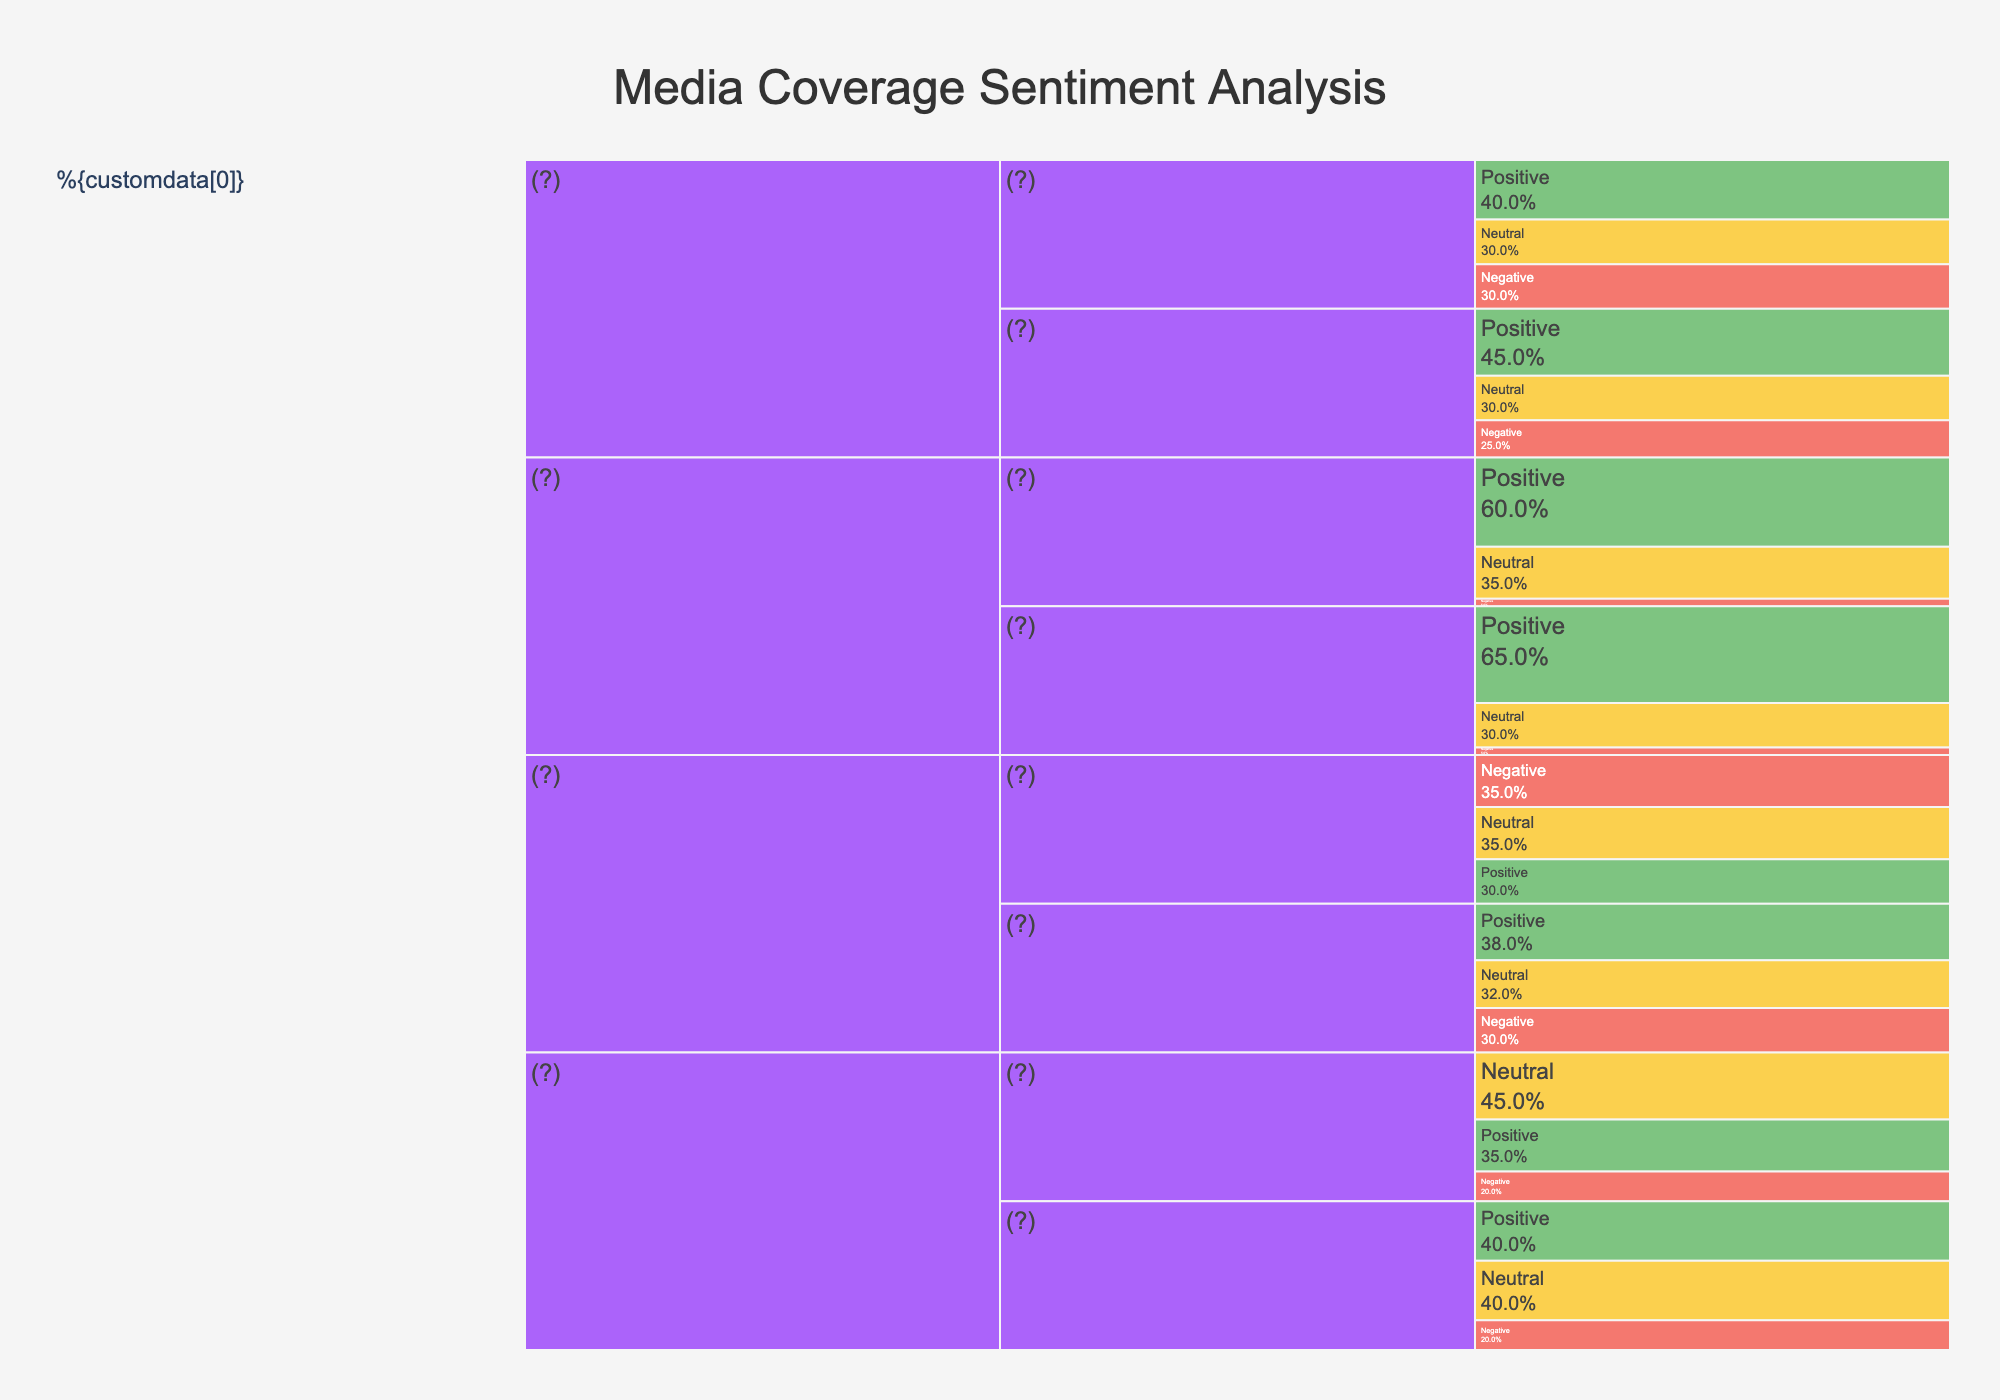What is the percentage of positive sentiment in Traditional Media during Q1 2023? To find the percentage of positive sentiment in Traditional Media during Q1 2023, look at the segment labeled 'Traditional Media > Q1 2023 > Positive' in the icicle chart. The percentage shown is 35%.
Answer: 35% What is the overall sentiment trend for Press Releases from Q1 to Q2 2023? Compare the sentiments (positive, neutral, negative) for Press Releases between Q1 and Q2 2023. Positive sentiment increased from 60% to 65%, neutral sentiment decreased from 35% to 30%, and negative sentiment remained constant at 5%. Thus, positive sentiment increased and neutral decreased while negative sentiment stayed the same.
Answer: Positive increased, neutral decreased, negative constant In which communication channel did the negative sentiment decrease the most from Q1 to Q2 2023? To determine where negative sentiment decreased the most, compare the negative sentiment percentages across all channels from Q1 to Q2. Social Media negative sentiment decreased from 35% to 30%, which is the largest decrease. Other channels showed no decrease or smaller changes.
Answer: Social Media How does the neutral sentiment in Traditional Media during Q1 2023 compare to that in Social Media during the same period? Examine both neutral sentiments for Traditional Media and Social Media in Q1 2023. Traditional Media has 45% neutral sentiment, whereas Social Media has 35%. Therefore, Traditional Media has a higher neutral sentiment.
Answer: Traditional Media has higher neutral sentiment What is the total percentage of positive sentiment across all communication channels in Q2 2023? Add the positive percentages for all channels in Q2 2023: Traditional Media (40%), Social Media (38%), Press Releases (65%), and Customer Reviews (45%). The total is 40% + 38% + 65% + 45% = 188%.
Answer: 188% Which channel had the highest percentage of negative sentiment in Q1 2023, and what was the percentage? Look for the highest negative sentiment percentage in Q1 2023 across all channels. Social Media has the highest negative sentiment at 35%.
Answer: Social Media, 35% Which communication channel showed the least change in negative sentiment from Q1 to Q2 2023? Investigate the change in negative sentiment across all channels from Q1 to Q2 2023. Both Press Releases and Traditional Media saw no change, with 5% and 20% respectively in both quarters. However, Social Media and Customer Reviews saw changes.
Answer: Press Releases and Traditional Media Is there any channel where the neutral sentiment remained the same from Q1 to Q2 2023? Compare the neutral sentiment percentages from Q1 to Q2 2023 for all channels. Neutral sentiment in Customer Reviews remained constant at 30%.
Answer: Customer Reviews What is the average percentage of positive sentiment across all channels in Q1 2023? Calculate the average by summing the positive percentages for Q1 2023 (Traditional Media 35%, Social Media 30%, Press Releases 60%, Customer Reviews 40%) and dividing by 4. The total is (35% + 30% + 60% + 40%) / 4 = 41.25%.
Answer: 41.25% What channel had the most balanced sentiment distribution (i.e., similar percentages for positive, neutral, and negative) in Q1 2023? Examine the sentiment percentages within each channel in Q1 2023. Social Media shows 30% positive, 35% neutral, and 35% negative, which are the most balanced proportions compared to other channels.
Answer: Social Media 